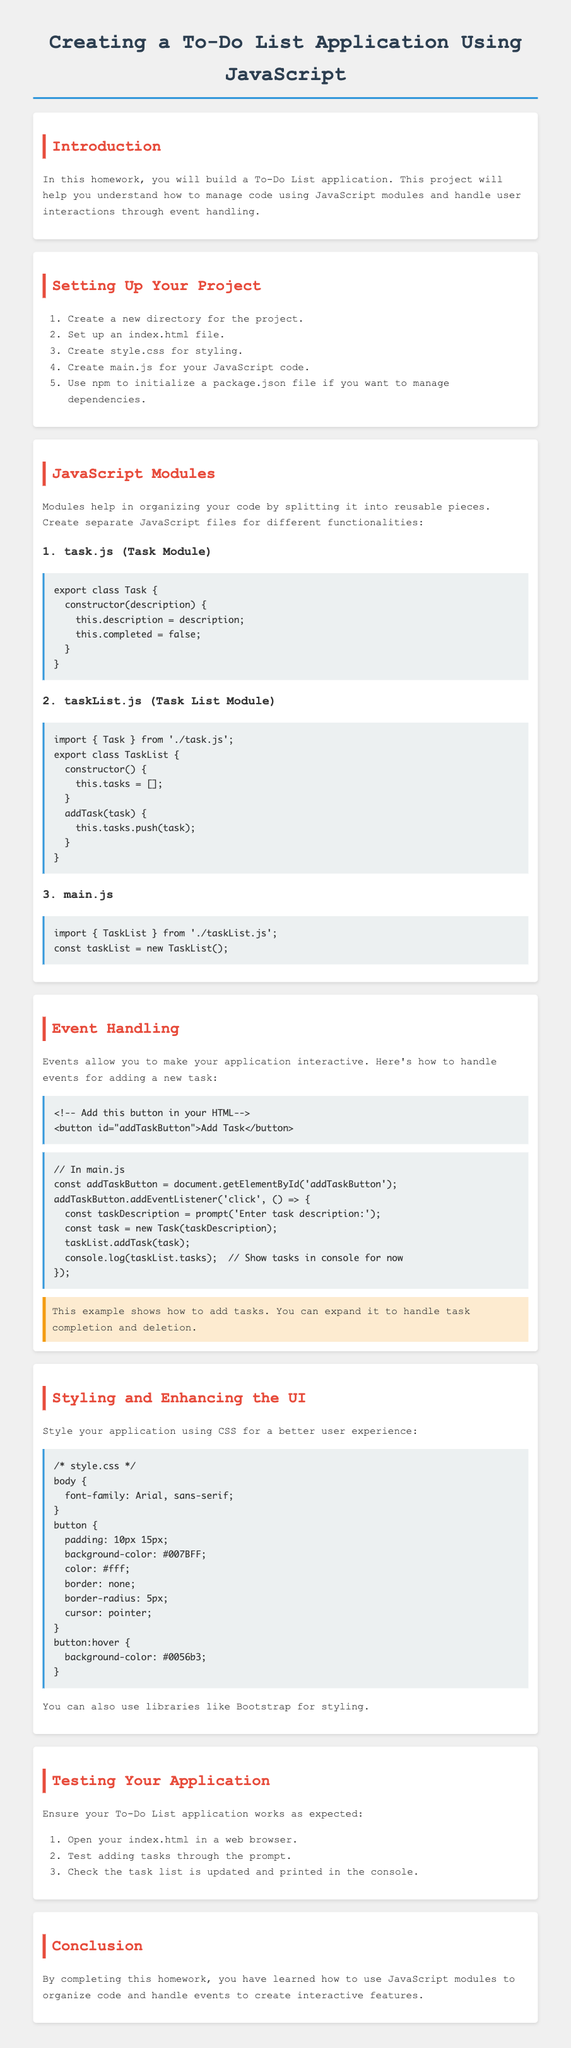What is the title of the homework? The title is mentioned at the beginning of the document as "Creating a To-Do List Application Using JavaScript."
Answer: Creating a To-Do List Application Using JavaScript How many modules are suggested for organizing the JavaScript code? Three separate modules are specified within the JavaScript Modules section: task.js, taskList.js, and main.js.
Answer: Three What is the name of the class defined in task.js? The class defined in task.js is specifically referred to as Task in the document.
Answer: Task What CSS property is used to style the button's background in style.css? The button's background is styled using the background-color property, as shown in the style.css section.
Answer: background-color What event is handled when the "Add Task" button is clicked? The click event is specified for handling user interaction when the "Add Task" button is activated.
Answer: click What is the purpose of using modules in the To-Do List application? Modules are used to organize code by splitting it into reusable pieces.
Answer: To organize code How does the document suggest testing the To-Do List application? The document outlines steps to test the application, including opening index.html in a web browser and adding tasks.
Answer: Open index.html in a web browser What color is suggested for the body font in style.css? The body font style is indicated to be Arial or sans-serif, as stated in the styling section.
Answer: Arial, sans-serif 